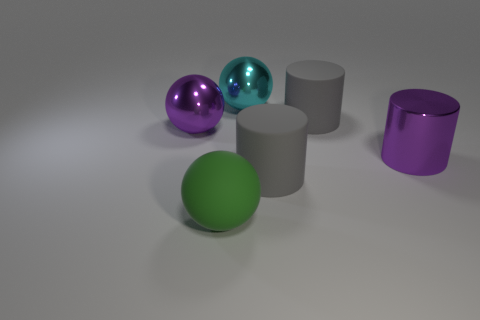Subtract all red cylinders. Subtract all blue balls. How many cylinders are left? 3 Add 3 small green shiny spheres. How many objects exist? 9 Subtract 0 gray blocks. How many objects are left? 6 Subtract all gray cylinders. Subtract all green matte things. How many objects are left? 3 Add 5 purple metal objects. How many purple metal objects are left? 7 Add 6 yellow metallic spheres. How many yellow metallic spheres exist? 6 